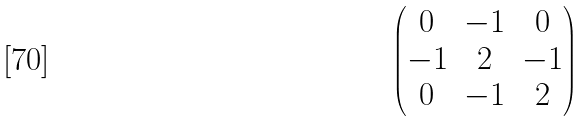<formula> <loc_0><loc_0><loc_500><loc_500>\begin{pmatrix} 0 & - 1 & 0 \\ - 1 & 2 & - 1 \\ 0 & - 1 & 2 \end{pmatrix}</formula> 